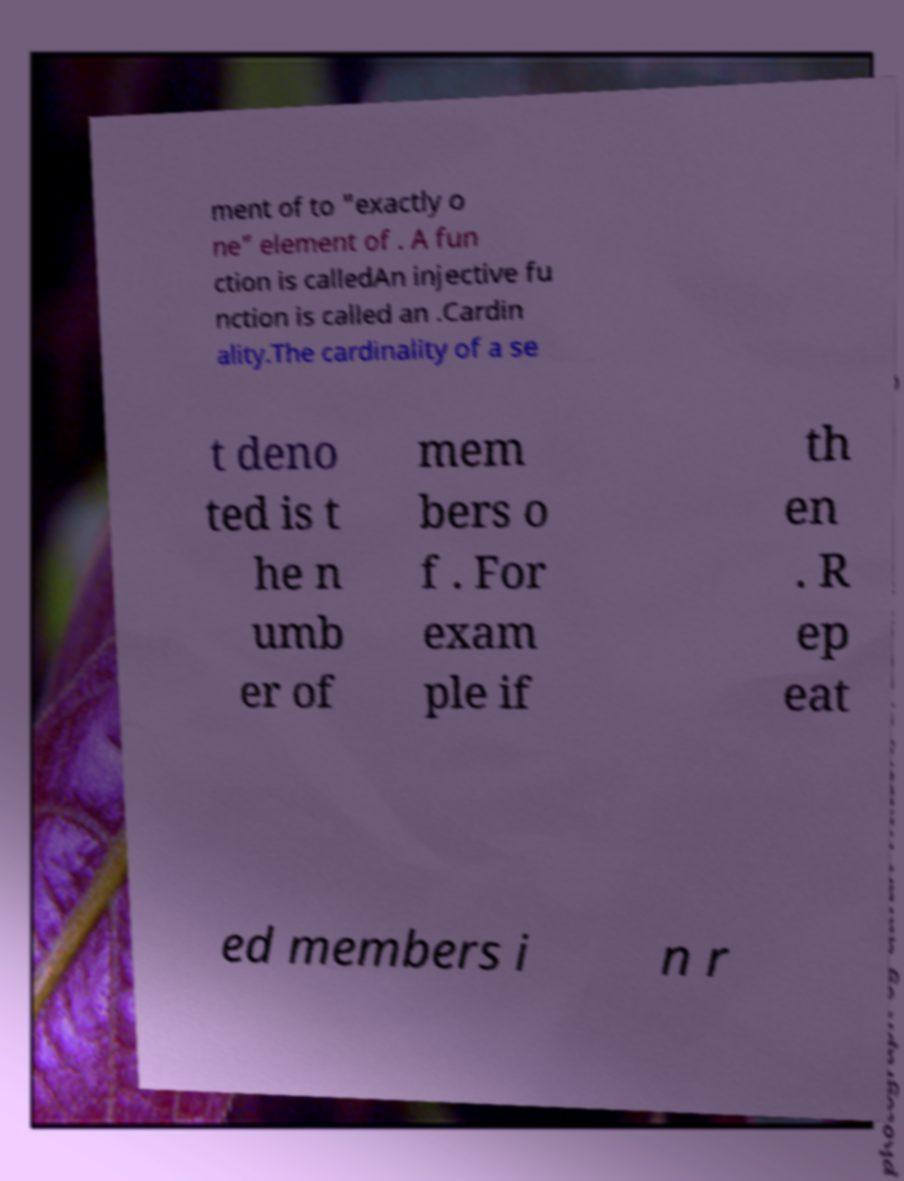What messages or text are displayed in this image? I need them in a readable, typed format. ment of to "exactly o ne" element of . A fun ction is calledAn injective fu nction is called an .Cardin ality.The cardinality of a se t deno ted is t he n umb er of mem bers o f . For exam ple if th en . R ep eat ed members i n r 